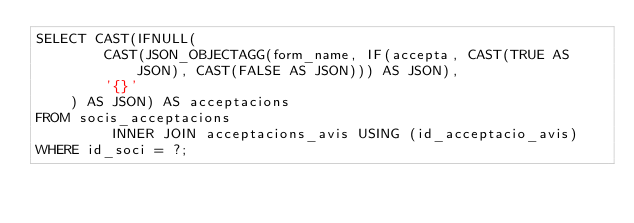Convert code to text. <code><loc_0><loc_0><loc_500><loc_500><_SQL_>SELECT CAST(IFNULL(
        CAST(JSON_OBJECTAGG(form_name, IF(accepta, CAST(TRUE AS JSON), CAST(FALSE AS JSON))) AS JSON),
        '{}'
    ) AS JSON) AS acceptacions
FROM socis_acceptacions
         INNER JOIN acceptacions_avis USING (id_acceptacio_avis)
WHERE id_soci = ?;
</code> 